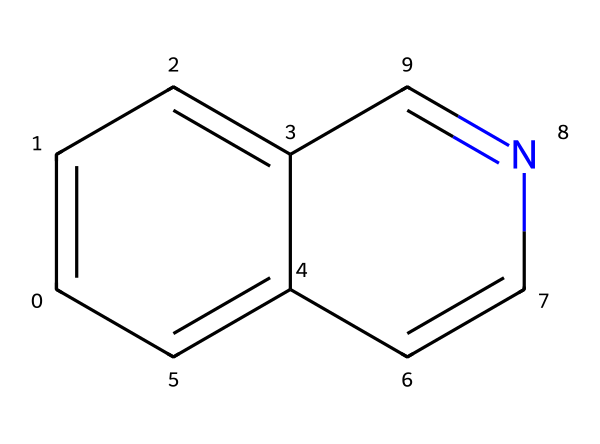What is the total number of carbon atoms in this structure? Counting the carbon atoms from the SMILES notation, there are six carbon atoms represented in the benzene-like ring and two more in the heterocycle, making a total of eight carbon atoms.
Answer: eight How many nitrogen atoms are present in this compound? Analyzing the structure, there is one nitrogen atom present in the heterocyclic part of the molecule, which is indicated in the SMILES representation.
Answer: one What type of functional group is present in this compound? The presence of the nitrogen atom in a heterocyclic aromatic compound indicates that this structure contains an amine functional group as part of its alkaloid nature.
Answer: amine What is the molecular formula of this compound? By counting all atoms represented in the SMILES string, we find it has 8 carbon atoms, 1 nitrogen atom, and 6 hydrogen atoms, resulting in the molecular formula C8H7N.
Answer: C8H7N What kind of secondary metabolites does this compound represent? This compound is recognized as a type of alkaloid, which are secondary metabolites commonly found in plants and known for their medicinal properties.
Answer: alkaloid Does this structure contain any rings? Observing the chemical structure reveals that it contains one fused ring system, characteristic of the quinoline family which combines aromaticity and heteroatoms.
Answer: yes 